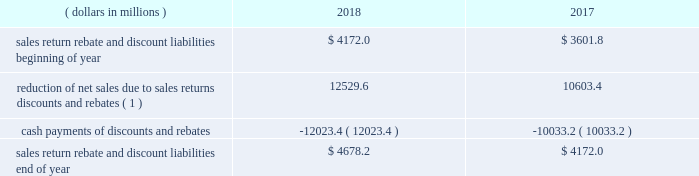Financial statement impact we believe that our accruals for sales returns , rebates , and discounts are reasonable and appropriate based on current facts and circumstances .
Our global rebate and discount liabilities are included in sales rebates and discounts on our consolidated balance sheet .
Our global sales return liability is included in other current liabilities and other noncurrent liabilities on our consolidated balance sheet .
As of december 31 , 2018 , a 5 percent change in our global sales return , rebate , and discount liability would have led to an approximate $ 275 million effect on our income before income taxes .
The portion of our global sales return , rebate , and discount liability resulting from sales of our products in the u.s .
Was approximately 90 percent as of december 31 , 2018 and december 31 , 2017 .
The following represents a roll-forward of our most significant u.s .
Pharmaceutical sales return , rebate , and discount liability balances , including managed care , medicare , and medicaid: .
( 1 ) adjustments of the estimates for these returns , rebates , and discounts to actual results were approximately 1 percent of consolidated net sales for each of the years presented .
Product litigation liabilities and other contingencies background and uncertainties product litigation liabilities and other contingencies are , by their nature , uncertain and based upon complex judgments and probabilities .
The factors we consider in developing our product litigation liability reserves and other contingent liability amounts include the merits and jurisdiction of the litigation , the nature and the number of other similar current and past matters , the nature of the product and the current assessment of the science subject to the litigation , and the likelihood of settlement and current state of settlement discussions , if any .
In addition , we accrue for certain product liability claims incurred , but not filed , to the extent we can formulate a reasonable estimate of their costs based primarily on historical claims experience and data regarding product usage .
We accrue legal defense costs expected to be incurred in connection with significant product liability contingencies when both probable and reasonably estimable .
We also consider the insurance coverage we have to diminish the exposure for periods covered by insurance .
In assessing our insurance coverage , we consider the policy coverage limits and exclusions , the potential for denial of coverage by the insurance company , the financial condition of the insurers , and the possibility of and length of time for collection .
Due to a very restrictive market for product liability insurance , we are self-insured for product liability losses for all our currently marketed products .
In addition to insurance coverage , we also consider any third-party indemnification to which we are entitled or under which we are obligated .
With respect to our third-party indemnification rights , these considerations include the nature of the indemnification , the financial condition of the indemnifying party , and the possibility of and length of time for collection .
The litigation accruals and environmental liabilities and the related estimated insurance recoverables have been reflected on a gross basis as liabilities and assets , respectively , on our consolidated balance sheets .
Impairment of indefinite-lived and long-lived assets background and uncertainties we review the carrying value of long-lived assets ( both intangible and tangible ) for potential impairment on a periodic basis and whenever events or changes in circumstances indicate the carrying value of an asset ( or asset group ) may not be recoverable .
We identify impairment by comparing the projected undiscounted cash flows to be generated by the asset ( or asset group ) to its carrying value .
If an impairment is identified , a loss is recorded equal to the excess of the asset 2019s net book value over its fair value , and the cost basis is adjusted .
Goodwill and indefinite-lived intangible assets are reviewed for impairment at least annually and when certain impairment indicators are present .
When required , a comparison of fair value to the carrying amount of assets is performed to determine the amount of any impairment. .
What was the percentage change in u.s . pharmaceutical sales return , rebate , and discount liability balances , including managed care , medicare , and medicaid between 2017 and 2018? 
Computations: ((4678.2 - 4172.0) / 4172.0)
Answer: 0.12133. 